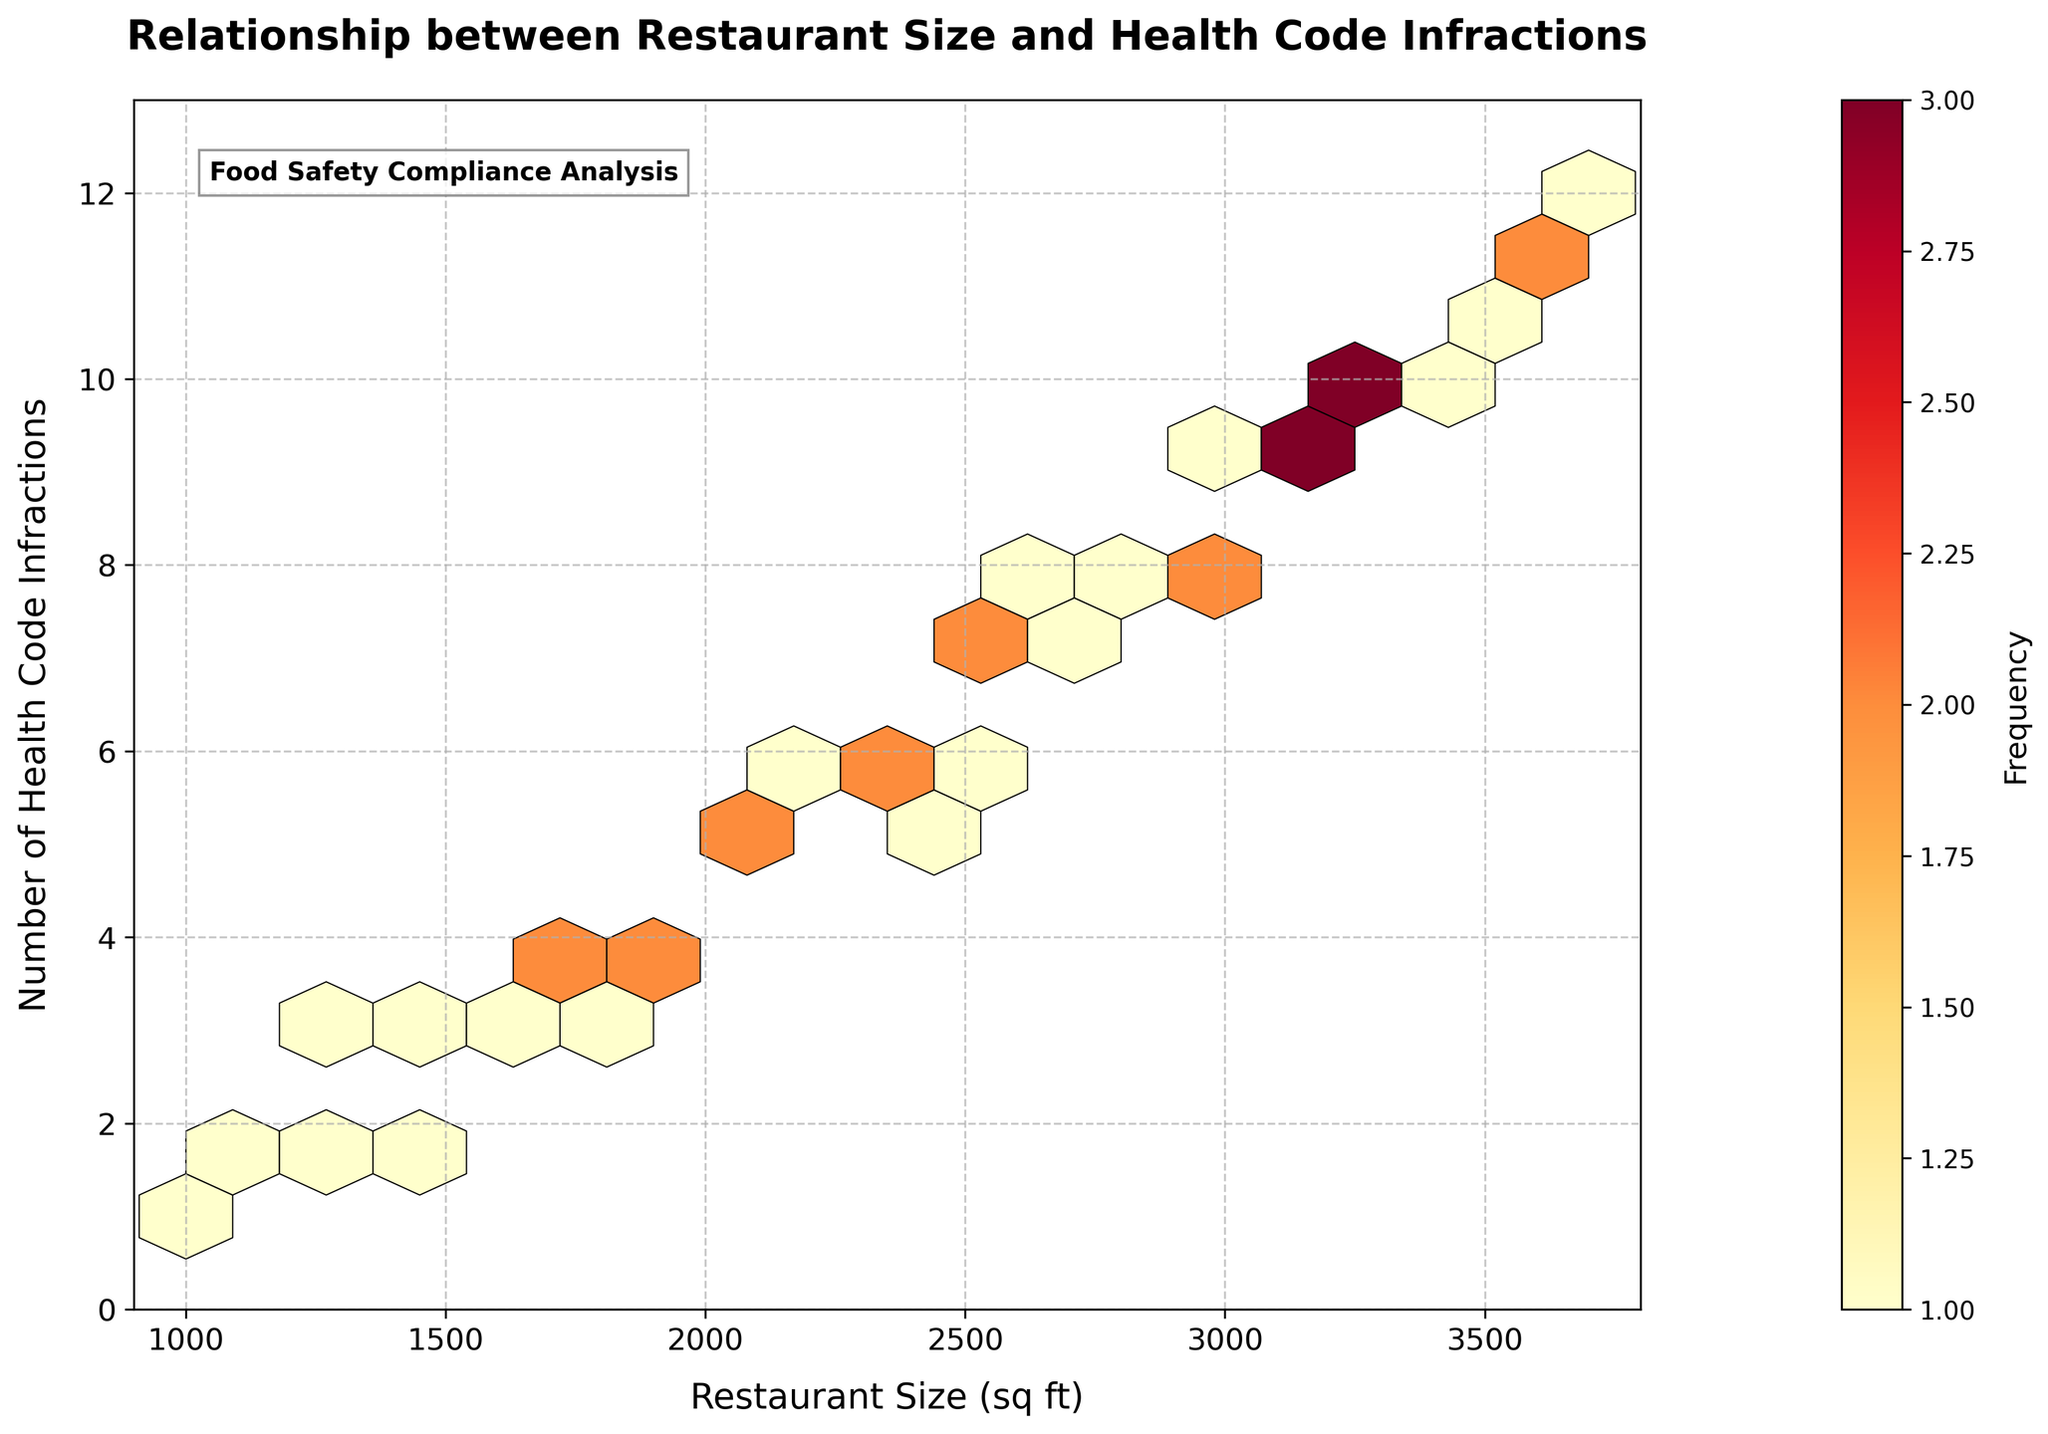What is the title of the figure? The title is displayed prominently at the top of the figure and reads "Relationship between Restaurant Size and Health Code Infractions".
Answer: Relationship between Restaurant Size and Health Code Infractions What are the axes labels? The x-axis label is "Restaurant Size (sq ft)" and the y-axis label is "Number of Health Code Infractions." This can be found along the respective axes.
Answer: Restaurant Size (sq ft), Number of Health Code Infractions What does the color of the hexagons represent? The color of the hexagons represents the frequency of data points within each hexagon, indicated by the colorbar. Yellower colors indicate lower frequency, while redder colors indicate higher frequency.
Answer: Frequency of data points In which range do most restaurants' sizes fall? Observe where the most overlapping hexagons are located along the x-axis, specifically around the 2500-3000 sq ft range.
Answer: 2500-3000 sq ft What is the range for the number of health code infractions? Look at the y-axis scale, which ranges from 0 to 13.
Answer: 0 to 13 Are there more health code infractions associated with larger restaurant sizes? Note the pattern and clustering in the plot. More data points with higher infraction values are clustered towards the larger restaurant sizes (3000-3500 sq ft).
Answer: Yes Which section contains the highest frequency of data points? The section with the highest frequency will be the hexagon with the most intense red color. This occurs around the size of 3100 sq ft and 9 infractions.
Answer: Around 3100 sq ft and 9 infractions Is there a linear relationship between restaurant size and the number of health code infractions? By observing the overall trend of the data points, it appears that as restaurant size increases, the number of infractions also increases, suggesting a positive linear relationship.
Answer: Yes How does the restaurant size of 2000 sq ft compare in terms of health code infractions to a restaurant size of 3600 sq ft? Locate the hexagons corresponding to 2000 sq ft and 3600 sq ft. You can see that 2000 sq ft has fewer infractions (around 5) compared to 3600 sq ft (around 11).
Answer: 2000 sq ft has fewer infractions than 3600 sq ft What does the grid size in the hexbin plot refer to? Grid size refers to the number of hexagons used to bin the data. In this plot, a grid size of 15 means that the x-axis and y-axis are divided into 15 intervals each.
Answer: It refers to the number of hexagons used to bin the data 